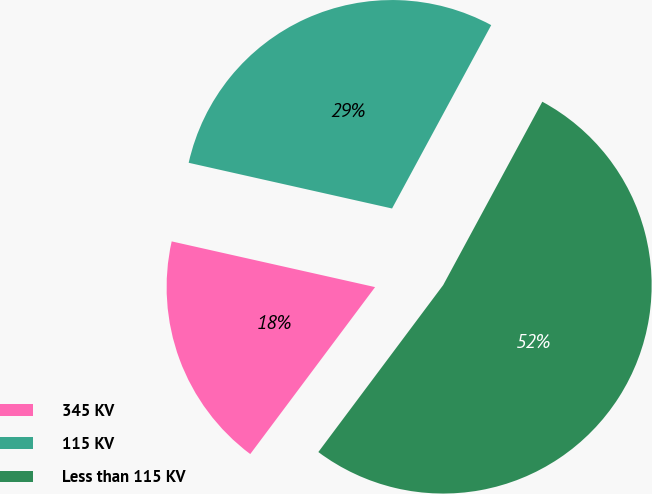<chart> <loc_0><loc_0><loc_500><loc_500><pie_chart><fcel>345 KV<fcel>115 KV<fcel>Less than 115 KV<nl><fcel>18.3%<fcel>29.37%<fcel>52.33%<nl></chart> 